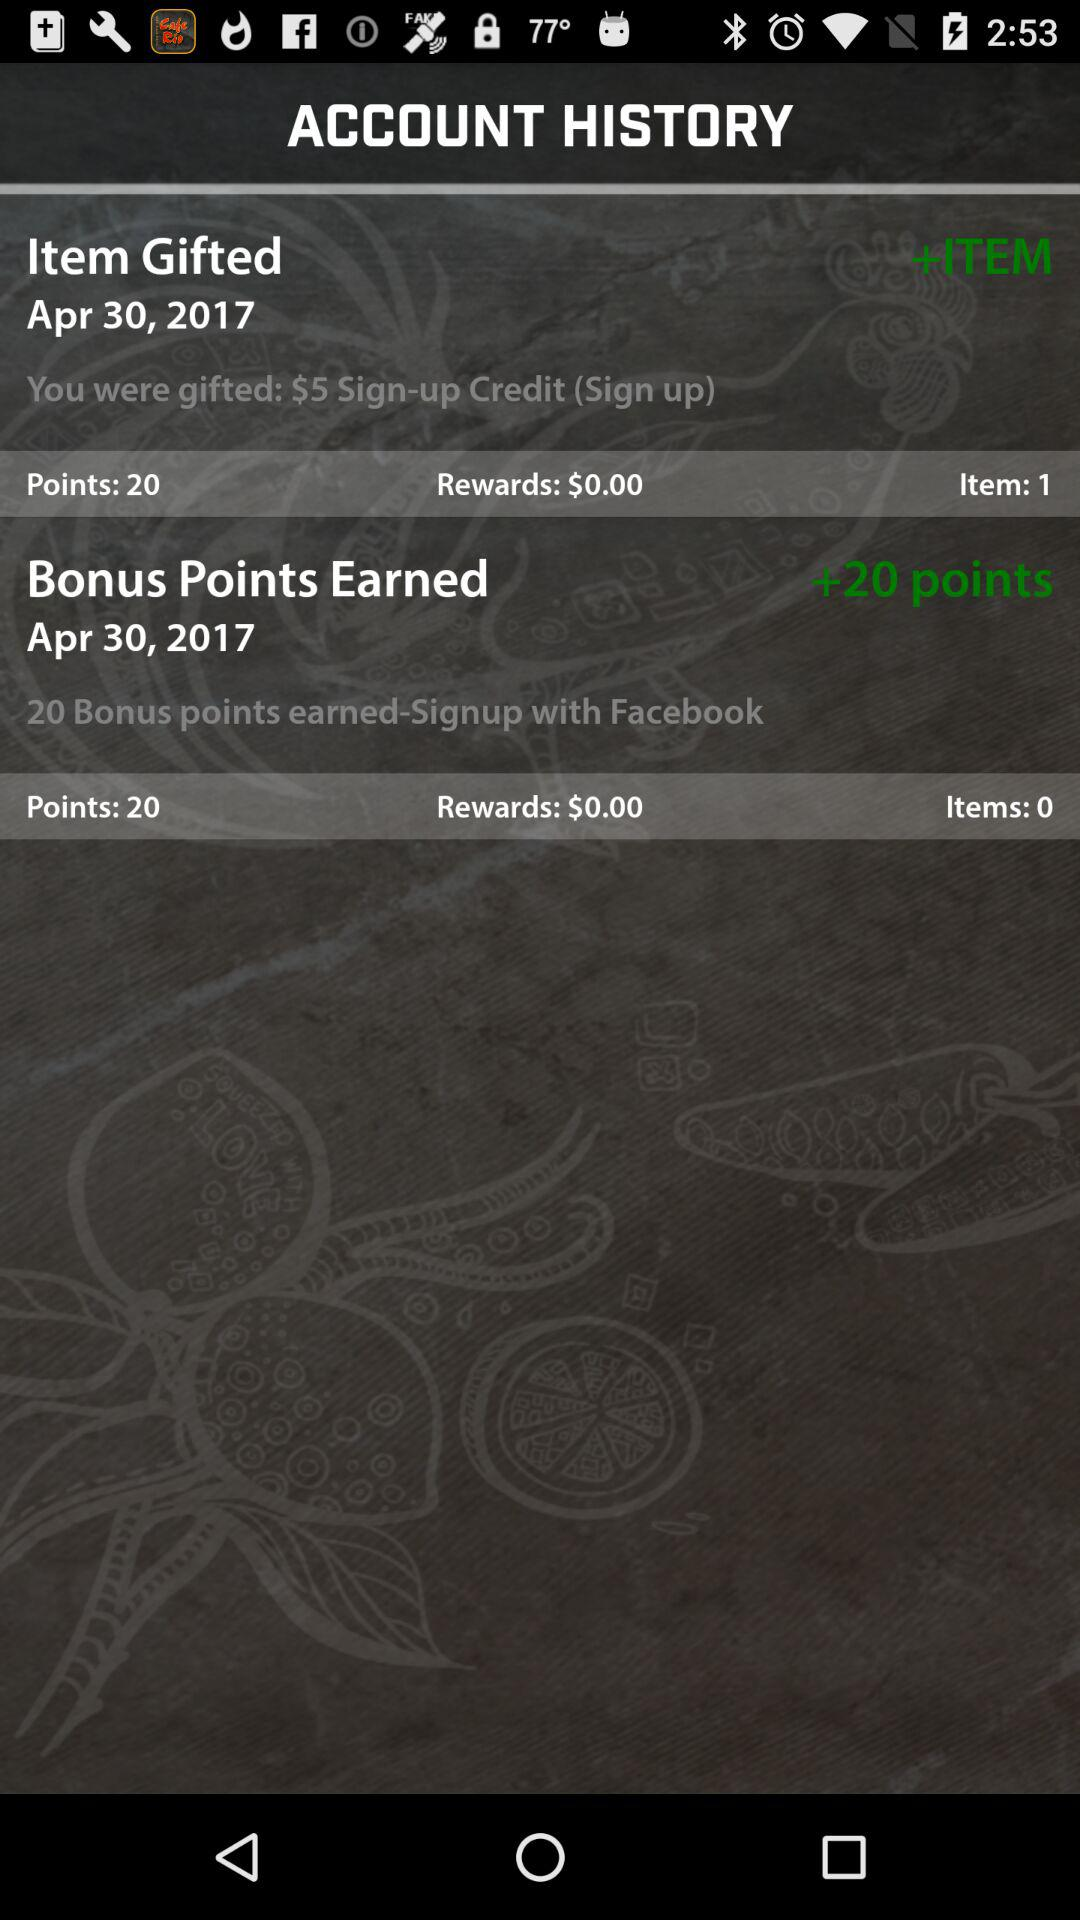What is the reward amount in "Item Gifted"? The reward amount is $0.00. 